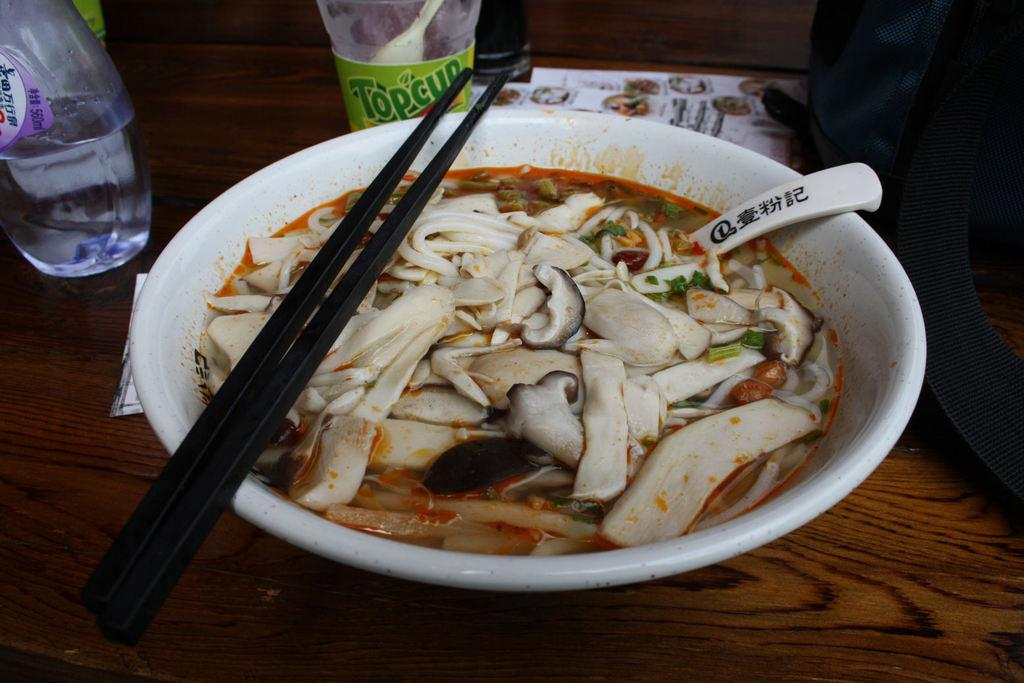<image>
Present a compact description of the photo's key features. A green Topcup bottle sits behind a bowl of Asian food. 